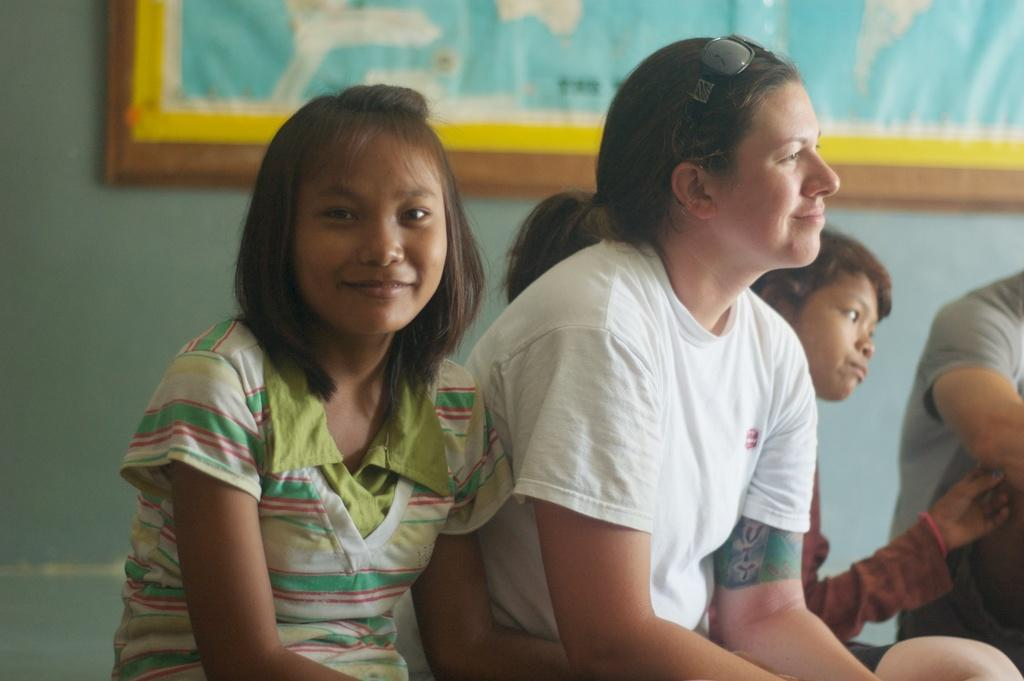How many people are in the image? There are a few people in the image. What can be seen in the background of the image? There is a wall in the background of the image. What is on the wall in the background? There is a board on the wall in the background. What type of bushes can be seen growing near the people in the image? There are no bushes present in the image; it only features a few people, a wall, and a board on the wall. 